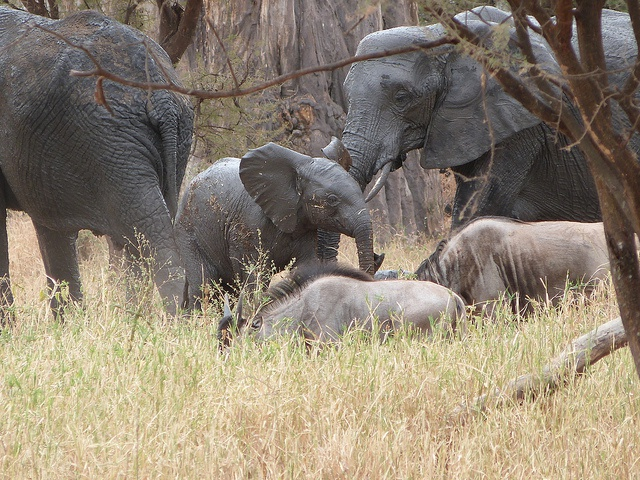Describe the objects in this image and their specific colors. I can see elephant in gray, black, and darkgray tones, elephant in gray and black tones, and elephant in gray, black, and darkgray tones in this image. 